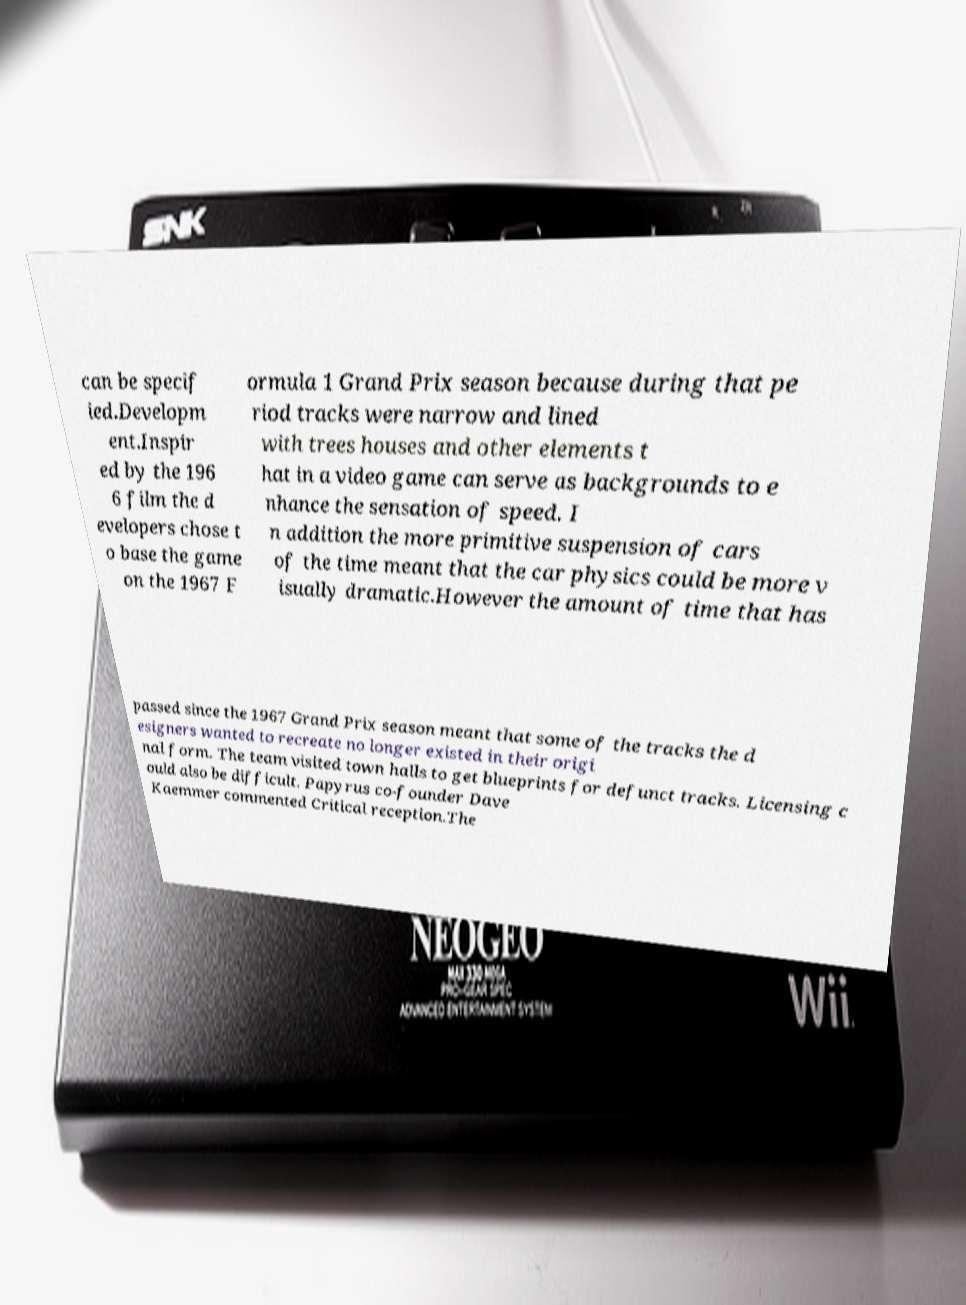Please read and relay the text visible in this image. What does it say? can be specif ied.Developm ent.Inspir ed by the 196 6 film the d evelopers chose t o base the game on the 1967 F ormula 1 Grand Prix season because during that pe riod tracks were narrow and lined with trees houses and other elements t hat in a video game can serve as backgrounds to e nhance the sensation of speed. I n addition the more primitive suspension of cars of the time meant that the car physics could be more v isually dramatic.However the amount of time that has passed since the 1967 Grand Prix season meant that some of the tracks the d esigners wanted to recreate no longer existed in their origi nal form. The team visited town halls to get blueprints for defunct tracks. Licensing c ould also be difficult. Papyrus co-founder Dave Kaemmer commented Critical reception.The 